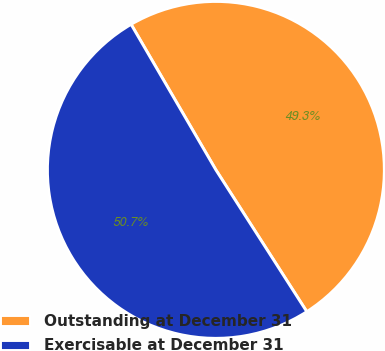<chart> <loc_0><loc_0><loc_500><loc_500><pie_chart><fcel>Outstanding at December 31<fcel>Exercisable at December 31<nl><fcel>49.32%<fcel>50.68%<nl></chart> 